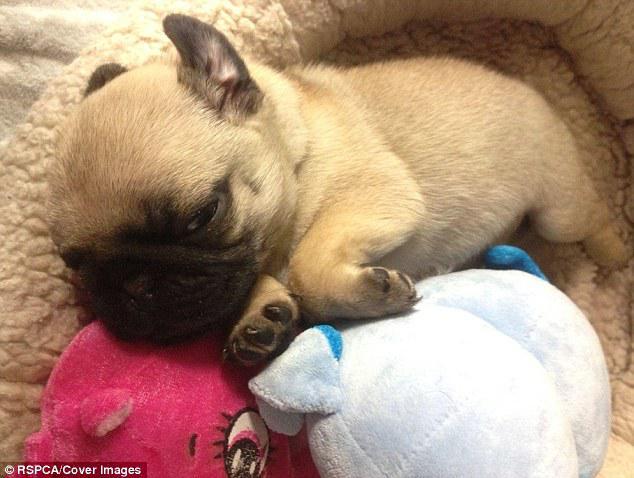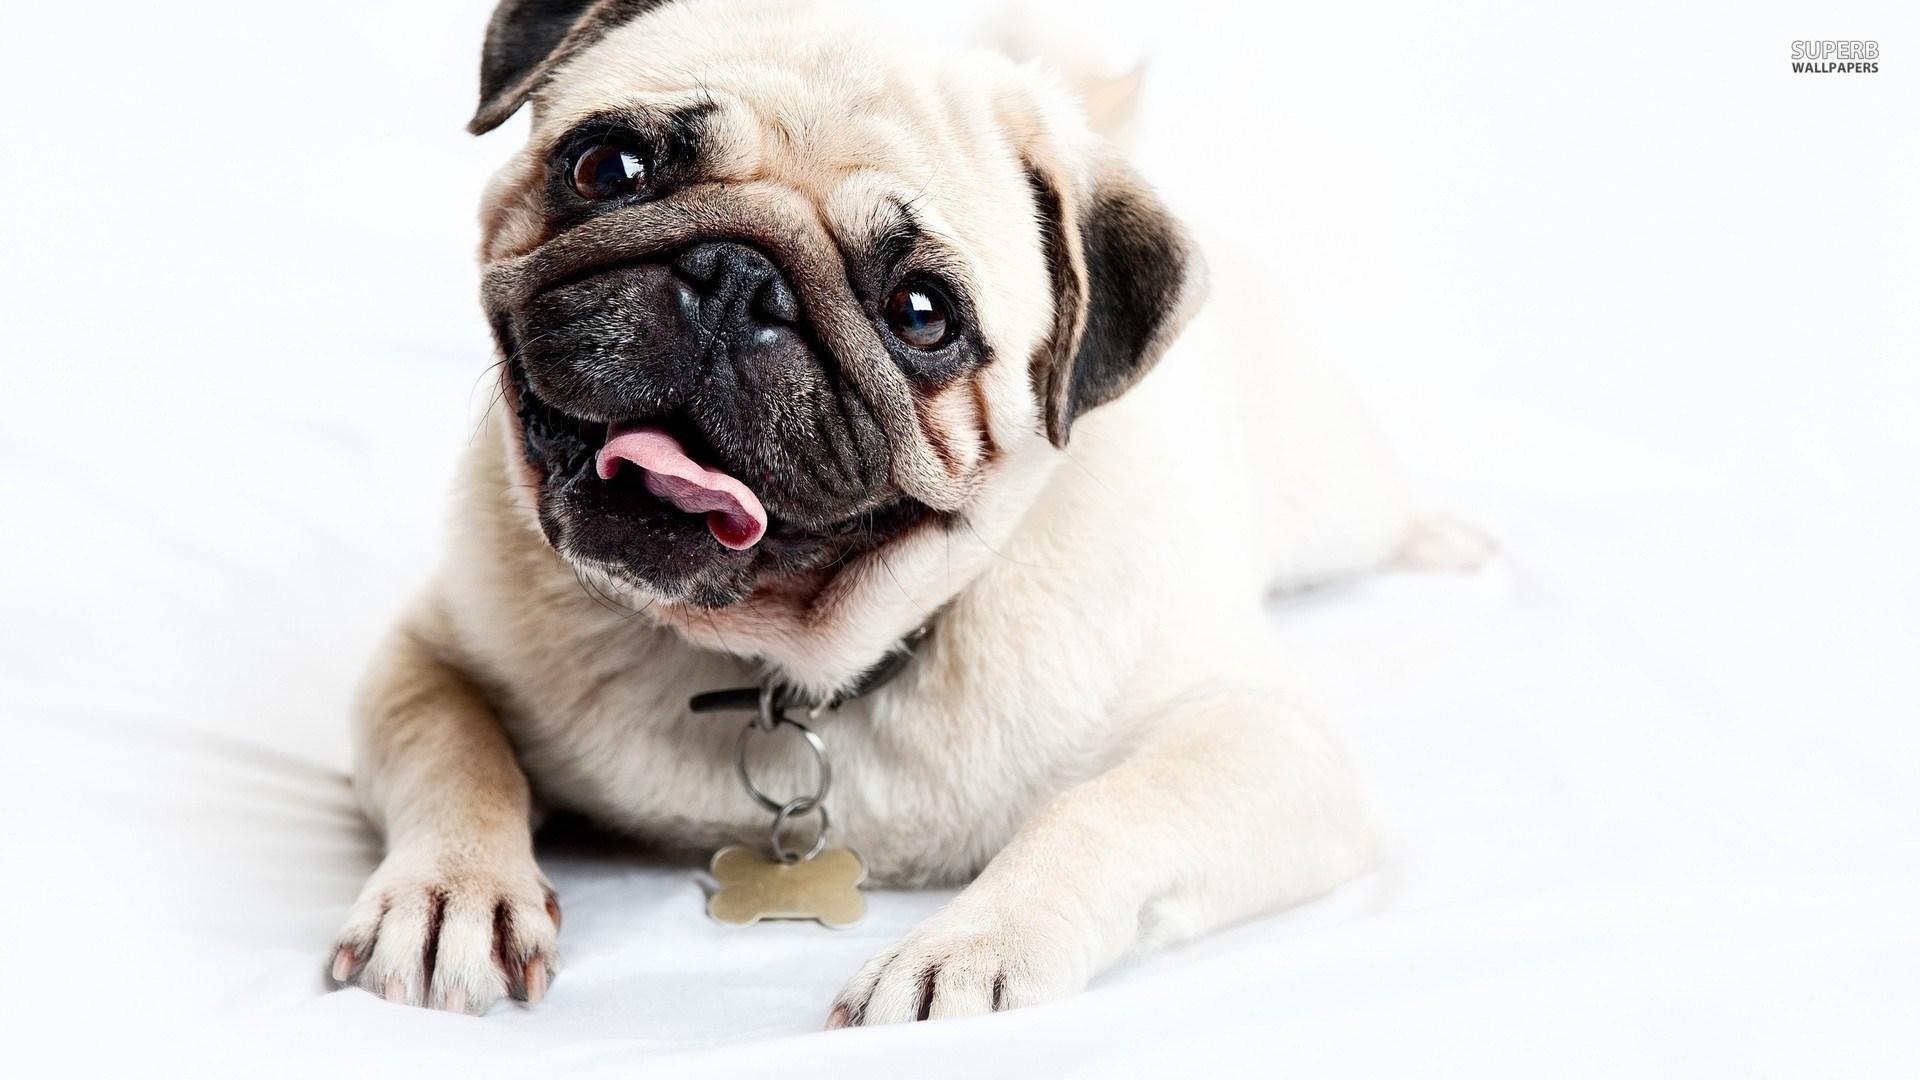The first image is the image on the left, the second image is the image on the right. Evaluate the accuracy of this statement regarding the images: "There is exactly one dog in every image and at least one dog is looking directly at the camera.". Is it true? Answer yes or no. Yes. The first image is the image on the left, the second image is the image on the right. Examine the images to the left and right. Is the description "The left image contains exactly one pug dog." accurate? Answer yes or no. Yes. 